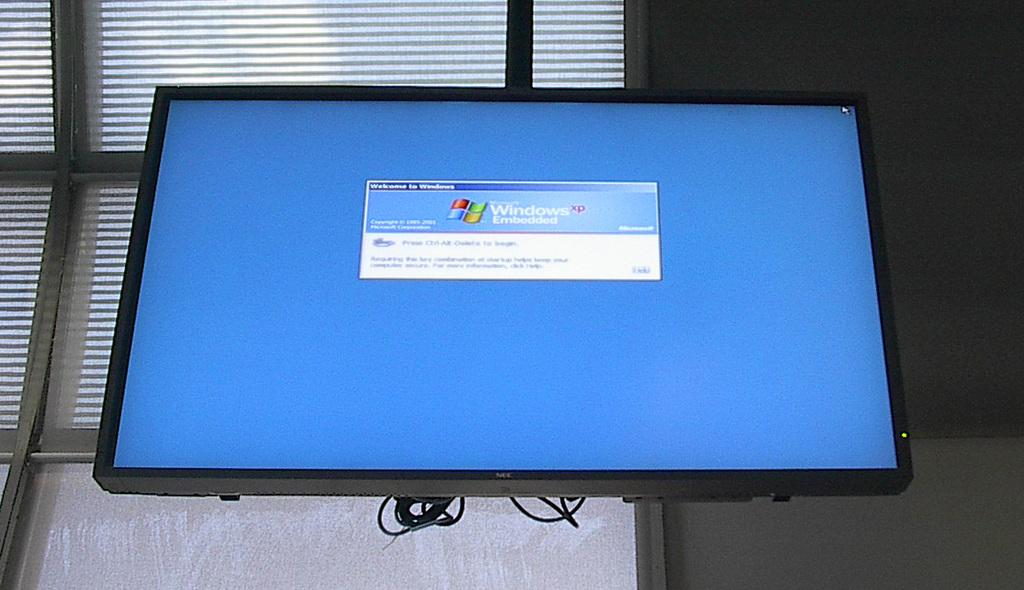<image>
Describe the image concisely. On the computer screen there is a message welcoming the person to windows. 